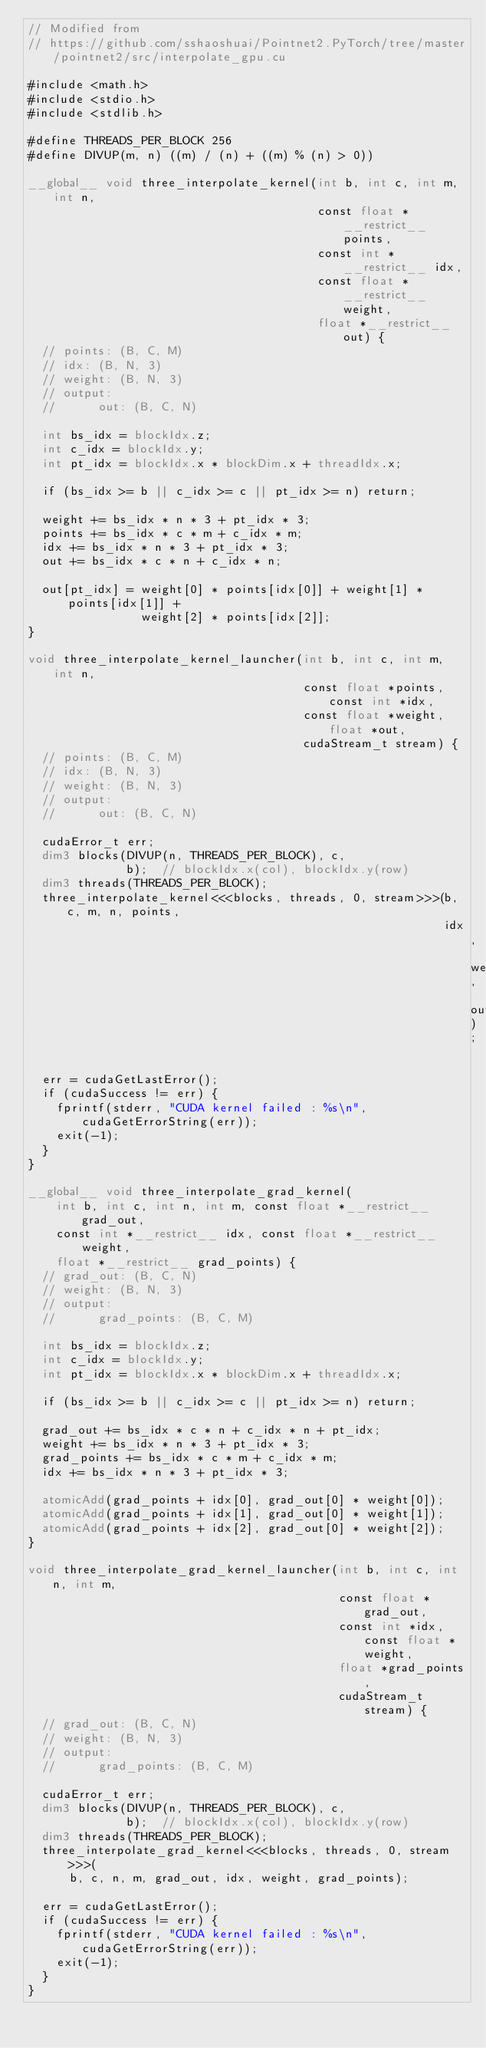<code> <loc_0><loc_0><loc_500><loc_500><_Cuda_>// Modified from
// https://github.com/sshaoshuai/Pointnet2.PyTorch/tree/master/pointnet2/src/interpolate_gpu.cu

#include <math.h>
#include <stdio.h>
#include <stdlib.h>

#define THREADS_PER_BLOCK 256
#define DIVUP(m, n) ((m) / (n) + ((m) % (n) > 0))

__global__ void three_interpolate_kernel(int b, int c, int m, int n,
                                         const float *__restrict__ points,
                                         const int *__restrict__ idx,
                                         const float *__restrict__ weight,
                                         float *__restrict__ out) {
  // points: (B, C, M)
  // idx: (B, N, 3)
  // weight: (B, N, 3)
  // output:
  //      out: (B, C, N)

  int bs_idx = blockIdx.z;
  int c_idx = blockIdx.y;
  int pt_idx = blockIdx.x * blockDim.x + threadIdx.x;

  if (bs_idx >= b || c_idx >= c || pt_idx >= n) return;

  weight += bs_idx * n * 3 + pt_idx * 3;
  points += bs_idx * c * m + c_idx * m;
  idx += bs_idx * n * 3 + pt_idx * 3;
  out += bs_idx * c * n + c_idx * n;

  out[pt_idx] = weight[0] * points[idx[0]] + weight[1] * points[idx[1]] +
                weight[2] * points[idx[2]];
}

void three_interpolate_kernel_launcher(int b, int c, int m, int n,
                                       const float *points, const int *idx,
                                       const float *weight, float *out,
                                       cudaStream_t stream) {
  // points: (B, C, M)
  // idx: (B, N, 3)
  // weight: (B, N, 3)
  // output:
  //      out: (B, C, N)

  cudaError_t err;
  dim3 blocks(DIVUP(n, THREADS_PER_BLOCK), c,
              b);  // blockIdx.x(col), blockIdx.y(row)
  dim3 threads(THREADS_PER_BLOCK);
  three_interpolate_kernel<<<blocks, threads, 0, stream>>>(b, c, m, n, points,
                                                           idx, weight, out);

  err = cudaGetLastError();
  if (cudaSuccess != err) {
    fprintf(stderr, "CUDA kernel failed : %s\n", cudaGetErrorString(err));
    exit(-1);
  }
}

__global__ void three_interpolate_grad_kernel(
    int b, int c, int n, int m, const float *__restrict__ grad_out,
    const int *__restrict__ idx, const float *__restrict__ weight,
    float *__restrict__ grad_points) {
  // grad_out: (B, C, N)
  // weight: (B, N, 3)
  // output:
  //      grad_points: (B, C, M)

  int bs_idx = blockIdx.z;
  int c_idx = blockIdx.y;
  int pt_idx = blockIdx.x * blockDim.x + threadIdx.x;

  if (bs_idx >= b || c_idx >= c || pt_idx >= n) return;

  grad_out += bs_idx * c * n + c_idx * n + pt_idx;
  weight += bs_idx * n * 3 + pt_idx * 3;
  grad_points += bs_idx * c * m + c_idx * m;
  idx += bs_idx * n * 3 + pt_idx * 3;

  atomicAdd(grad_points + idx[0], grad_out[0] * weight[0]);
  atomicAdd(grad_points + idx[1], grad_out[0] * weight[1]);
  atomicAdd(grad_points + idx[2], grad_out[0] * weight[2]);
}

void three_interpolate_grad_kernel_launcher(int b, int c, int n, int m,
                                            const float *grad_out,
                                            const int *idx, const float *weight,
                                            float *grad_points,
                                            cudaStream_t stream) {
  // grad_out: (B, C, N)
  // weight: (B, N, 3)
  // output:
  //      grad_points: (B, C, M)

  cudaError_t err;
  dim3 blocks(DIVUP(n, THREADS_PER_BLOCK), c,
              b);  // blockIdx.x(col), blockIdx.y(row)
  dim3 threads(THREADS_PER_BLOCK);
  three_interpolate_grad_kernel<<<blocks, threads, 0, stream>>>(
      b, c, n, m, grad_out, idx, weight, grad_points);

  err = cudaGetLastError();
  if (cudaSuccess != err) {
    fprintf(stderr, "CUDA kernel failed : %s\n", cudaGetErrorString(err));
    exit(-1);
  }
}
</code> 